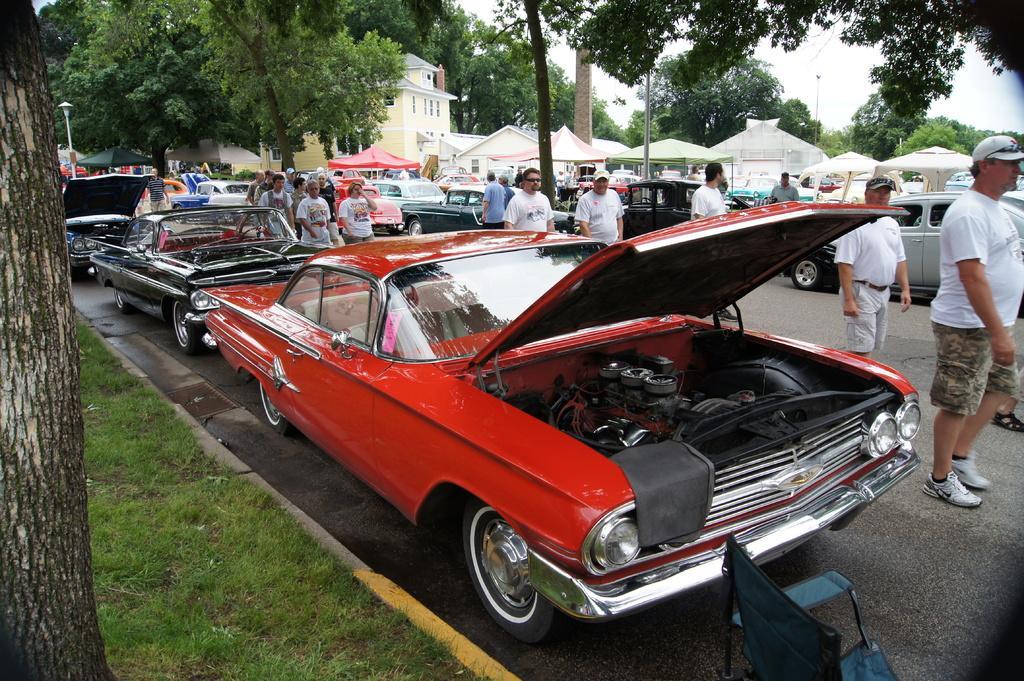In one or two sentences, can you explain what this image depicts? In this image there is a road, on that road vehicles are parked people are walking on the road, in the background there are trees and tents. 